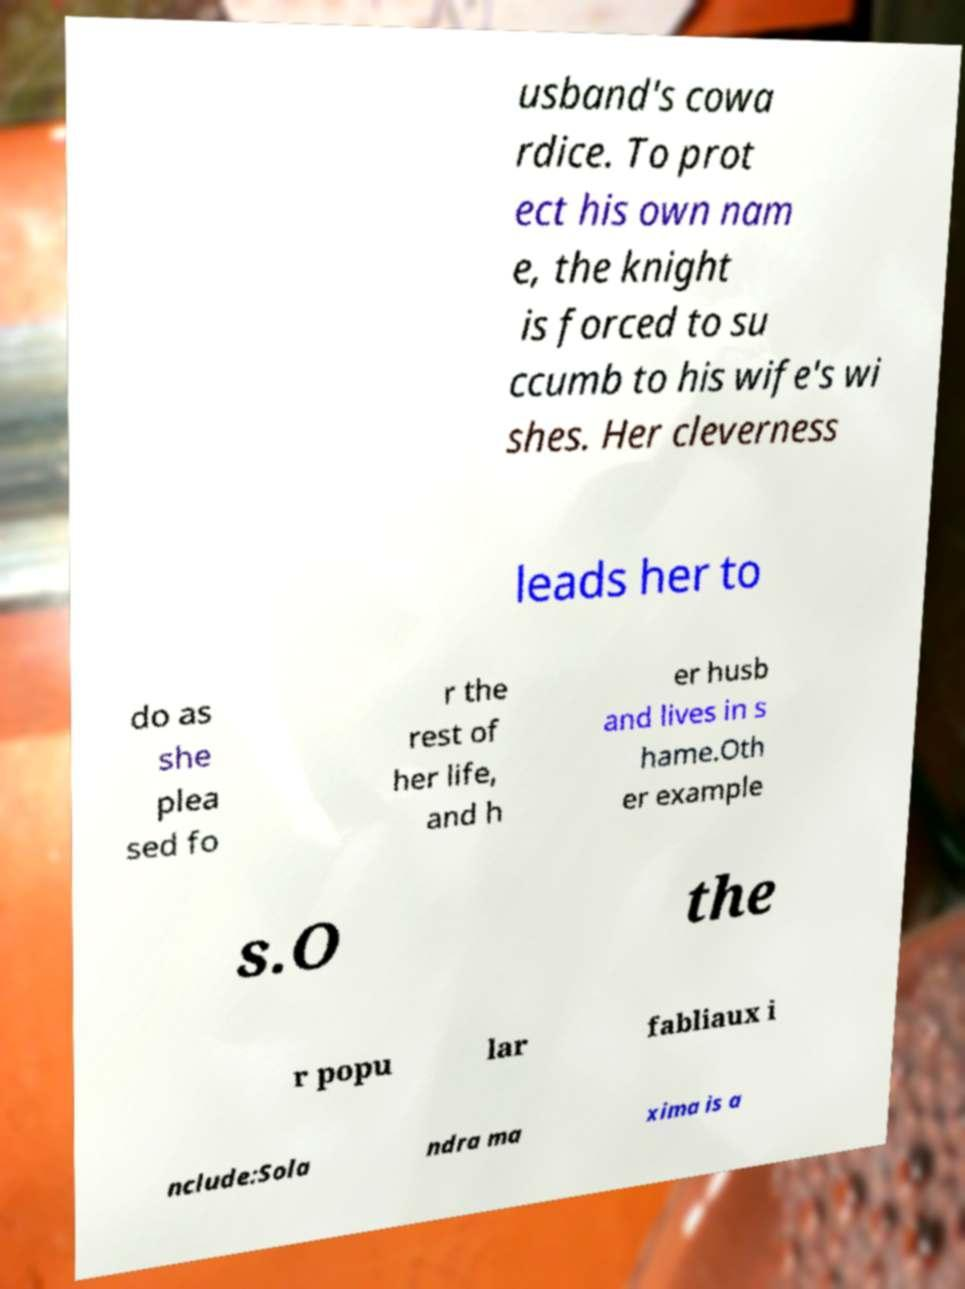I need the written content from this picture converted into text. Can you do that? usband's cowa rdice. To prot ect his own nam e, the knight is forced to su ccumb to his wife's wi shes. Her cleverness leads her to do as she plea sed fo r the rest of her life, and h er husb and lives in s hame.Oth er example s.O the r popu lar fabliaux i nclude:Sola ndra ma xima is a 